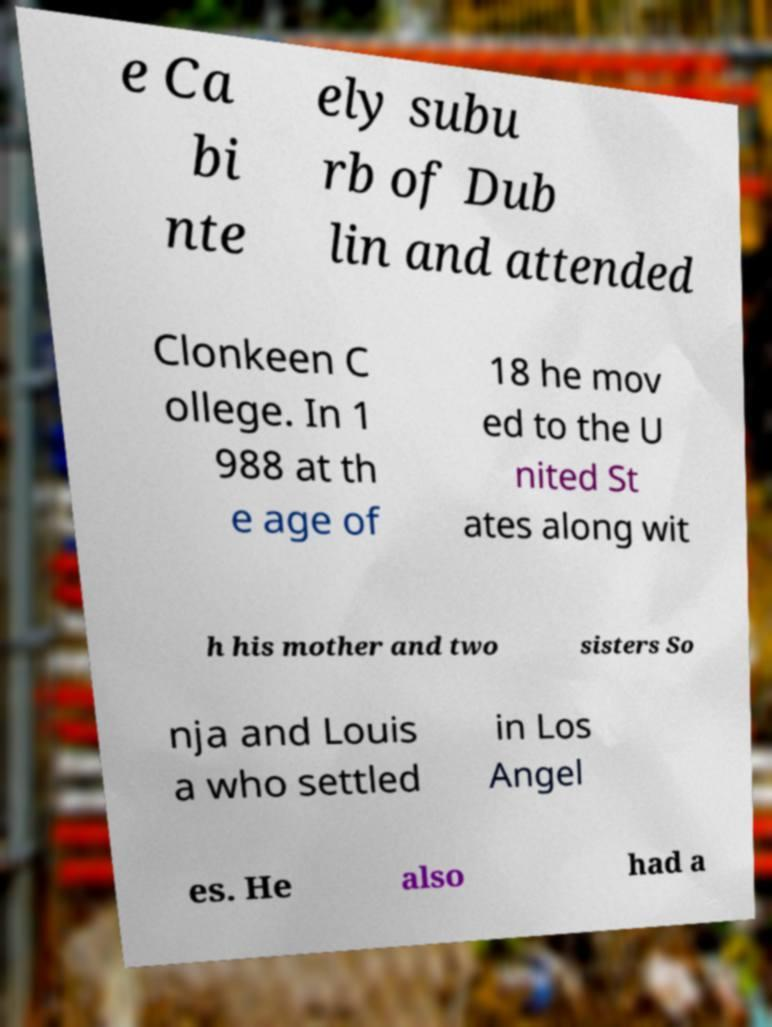There's text embedded in this image that I need extracted. Can you transcribe it verbatim? e Ca bi nte ely subu rb of Dub lin and attended Clonkeen C ollege. In 1 988 at th e age of 18 he mov ed to the U nited St ates along wit h his mother and two sisters So nja and Louis a who settled in Los Angel es. He also had a 